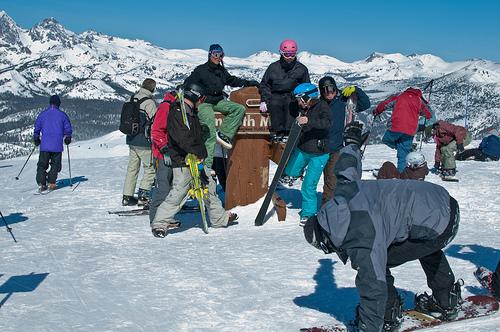How is the weather?
Keep it brief. Cold. What are the people standing on?
Be succinct. Snow. Which way are the shadows cast?
Write a very short answer. South. How many people have pink helmets?
Give a very brief answer. 1. 